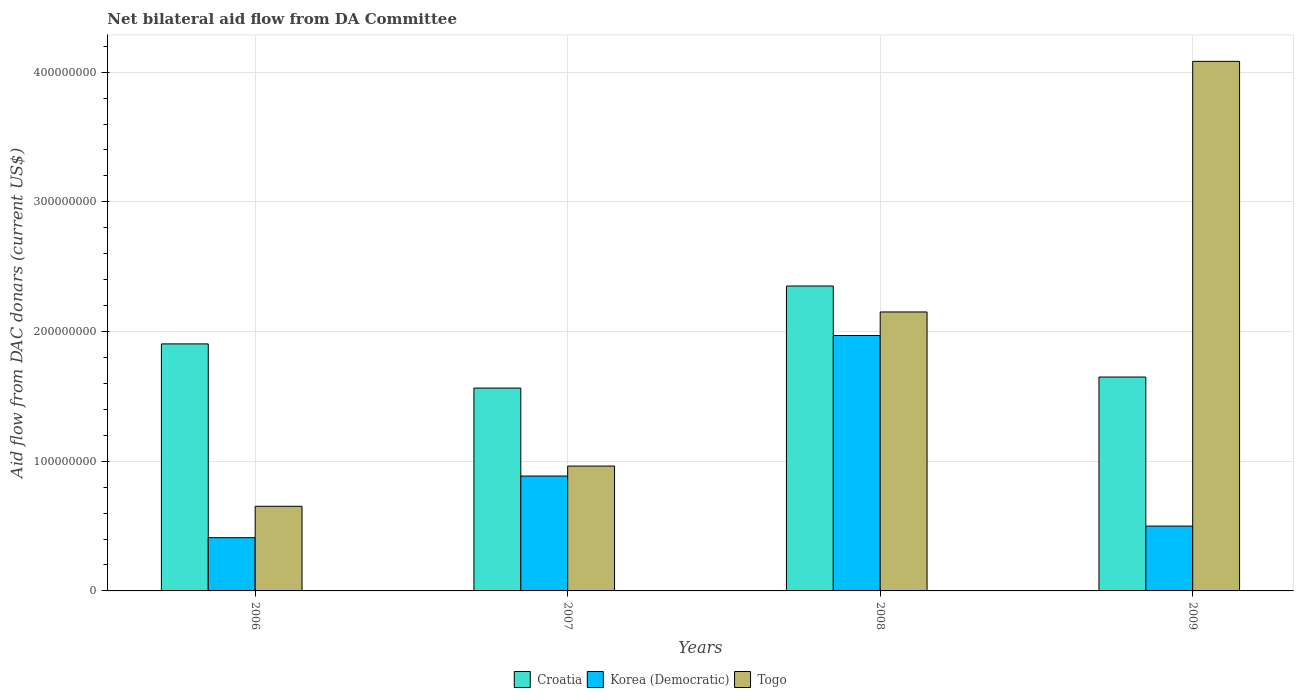How many different coloured bars are there?
Offer a terse response. 3. How many groups of bars are there?
Give a very brief answer. 4. Are the number of bars on each tick of the X-axis equal?
Give a very brief answer. Yes. How many bars are there on the 4th tick from the left?
Ensure brevity in your answer.  3. In how many cases, is the number of bars for a given year not equal to the number of legend labels?
Provide a succinct answer. 0. What is the aid flow in in Croatia in 2009?
Provide a succinct answer. 1.65e+08. Across all years, what is the maximum aid flow in in Korea (Democratic)?
Your answer should be very brief. 1.97e+08. Across all years, what is the minimum aid flow in in Croatia?
Your answer should be compact. 1.56e+08. In which year was the aid flow in in Togo maximum?
Provide a succinct answer. 2009. What is the total aid flow in in Korea (Democratic) in the graph?
Your answer should be compact. 3.77e+08. What is the difference between the aid flow in in Croatia in 2007 and that in 2009?
Provide a short and direct response. -8.51e+06. What is the difference between the aid flow in in Togo in 2008 and the aid flow in in Korea (Democratic) in 2009?
Your answer should be very brief. 1.65e+08. What is the average aid flow in in Korea (Democratic) per year?
Your answer should be very brief. 9.41e+07. In the year 2008, what is the difference between the aid flow in in Croatia and aid flow in in Korea (Democratic)?
Offer a very short reply. 3.82e+07. What is the ratio of the aid flow in in Korea (Democratic) in 2007 to that in 2009?
Your response must be concise. 1.77. Is the aid flow in in Korea (Democratic) in 2006 less than that in 2007?
Make the answer very short. Yes. What is the difference between the highest and the second highest aid flow in in Croatia?
Your answer should be very brief. 4.46e+07. What is the difference between the highest and the lowest aid flow in in Togo?
Your answer should be very brief. 3.43e+08. What does the 2nd bar from the left in 2009 represents?
Offer a very short reply. Korea (Democratic). What does the 1st bar from the right in 2006 represents?
Make the answer very short. Togo. How many bars are there?
Make the answer very short. 12. Are all the bars in the graph horizontal?
Your answer should be compact. No. How many years are there in the graph?
Provide a succinct answer. 4. What is the difference between two consecutive major ticks on the Y-axis?
Your answer should be compact. 1.00e+08. Does the graph contain any zero values?
Ensure brevity in your answer.  No. Does the graph contain grids?
Offer a very short reply. Yes. Where does the legend appear in the graph?
Offer a terse response. Bottom center. How many legend labels are there?
Provide a short and direct response. 3. How are the legend labels stacked?
Provide a short and direct response. Horizontal. What is the title of the graph?
Make the answer very short. Net bilateral aid flow from DA Committee. Does "Sri Lanka" appear as one of the legend labels in the graph?
Give a very brief answer. No. What is the label or title of the Y-axis?
Keep it short and to the point. Aid flow from DAC donars (current US$). What is the Aid flow from DAC donars (current US$) of Croatia in 2006?
Ensure brevity in your answer.  1.90e+08. What is the Aid flow from DAC donars (current US$) in Korea (Democratic) in 2006?
Provide a succinct answer. 4.10e+07. What is the Aid flow from DAC donars (current US$) in Togo in 2006?
Keep it short and to the point. 6.52e+07. What is the Aid flow from DAC donars (current US$) of Croatia in 2007?
Your answer should be compact. 1.56e+08. What is the Aid flow from DAC donars (current US$) in Korea (Democratic) in 2007?
Provide a succinct answer. 8.86e+07. What is the Aid flow from DAC donars (current US$) in Togo in 2007?
Your answer should be compact. 9.63e+07. What is the Aid flow from DAC donars (current US$) in Croatia in 2008?
Give a very brief answer. 2.35e+08. What is the Aid flow from DAC donars (current US$) in Korea (Democratic) in 2008?
Offer a terse response. 1.97e+08. What is the Aid flow from DAC donars (current US$) in Togo in 2008?
Make the answer very short. 2.15e+08. What is the Aid flow from DAC donars (current US$) of Croatia in 2009?
Your answer should be compact. 1.65e+08. What is the Aid flow from DAC donars (current US$) of Korea (Democratic) in 2009?
Provide a succinct answer. 5.00e+07. What is the Aid flow from DAC donars (current US$) of Togo in 2009?
Your answer should be compact. 4.08e+08. Across all years, what is the maximum Aid flow from DAC donars (current US$) in Croatia?
Keep it short and to the point. 2.35e+08. Across all years, what is the maximum Aid flow from DAC donars (current US$) in Korea (Democratic)?
Provide a succinct answer. 1.97e+08. Across all years, what is the maximum Aid flow from DAC donars (current US$) in Togo?
Provide a short and direct response. 4.08e+08. Across all years, what is the minimum Aid flow from DAC donars (current US$) of Croatia?
Give a very brief answer. 1.56e+08. Across all years, what is the minimum Aid flow from DAC donars (current US$) of Korea (Democratic)?
Your answer should be very brief. 4.10e+07. Across all years, what is the minimum Aid flow from DAC donars (current US$) in Togo?
Your answer should be very brief. 6.52e+07. What is the total Aid flow from DAC donars (current US$) of Croatia in the graph?
Provide a short and direct response. 7.47e+08. What is the total Aid flow from DAC donars (current US$) in Korea (Democratic) in the graph?
Ensure brevity in your answer.  3.77e+08. What is the total Aid flow from DAC donars (current US$) of Togo in the graph?
Your response must be concise. 7.85e+08. What is the difference between the Aid flow from DAC donars (current US$) in Croatia in 2006 and that in 2007?
Make the answer very short. 3.41e+07. What is the difference between the Aid flow from DAC donars (current US$) of Korea (Democratic) in 2006 and that in 2007?
Ensure brevity in your answer.  -4.75e+07. What is the difference between the Aid flow from DAC donars (current US$) of Togo in 2006 and that in 2007?
Provide a short and direct response. -3.10e+07. What is the difference between the Aid flow from DAC donars (current US$) in Croatia in 2006 and that in 2008?
Offer a very short reply. -4.46e+07. What is the difference between the Aid flow from DAC donars (current US$) in Korea (Democratic) in 2006 and that in 2008?
Make the answer very short. -1.56e+08. What is the difference between the Aid flow from DAC donars (current US$) of Togo in 2006 and that in 2008?
Ensure brevity in your answer.  -1.50e+08. What is the difference between the Aid flow from DAC donars (current US$) of Croatia in 2006 and that in 2009?
Your answer should be compact. 2.56e+07. What is the difference between the Aid flow from DAC donars (current US$) of Korea (Democratic) in 2006 and that in 2009?
Keep it short and to the point. -8.93e+06. What is the difference between the Aid flow from DAC donars (current US$) in Togo in 2006 and that in 2009?
Provide a succinct answer. -3.43e+08. What is the difference between the Aid flow from DAC donars (current US$) of Croatia in 2007 and that in 2008?
Offer a terse response. -7.87e+07. What is the difference between the Aid flow from DAC donars (current US$) of Korea (Democratic) in 2007 and that in 2008?
Offer a very short reply. -1.08e+08. What is the difference between the Aid flow from DAC donars (current US$) of Togo in 2007 and that in 2008?
Keep it short and to the point. -1.19e+08. What is the difference between the Aid flow from DAC donars (current US$) in Croatia in 2007 and that in 2009?
Ensure brevity in your answer.  -8.51e+06. What is the difference between the Aid flow from DAC donars (current US$) in Korea (Democratic) in 2007 and that in 2009?
Keep it short and to the point. 3.86e+07. What is the difference between the Aid flow from DAC donars (current US$) in Togo in 2007 and that in 2009?
Your answer should be very brief. -3.12e+08. What is the difference between the Aid flow from DAC donars (current US$) in Croatia in 2008 and that in 2009?
Offer a terse response. 7.02e+07. What is the difference between the Aid flow from DAC donars (current US$) of Korea (Democratic) in 2008 and that in 2009?
Ensure brevity in your answer.  1.47e+08. What is the difference between the Aid flow from DAC donars (current US$) in Togo in 2008 and that in 2009?
Your answer should be very brief. -1.93e+08. What is the difference between the Aid flow from DAC donars (current US$) in Croatia in 2006 and the Aid flow from DAC donars (current US$) in Korea (Democratic) in 2007?
Make the answer very short. 1.02e+08. What is the difference between the Aid flow from DAC donars (current US$) of Croatia in 2006 and the Aid flow from DAC donars (current US$) of Togo in 2007?
Provide a succinct answer. 9.42e+07. What is the difference between the Aid flow from DAC donars (current US$) of Korea (Democratic) in 2006 and the Aid flow from DAC donars (current US$) of Togo in 2007?
Your answer should be compact. -5.52e+07. What is the difference between the Aid flow from DAC donars (current US$) in Croatia in 2006 and the Aid flow from DAC donars (current US$) in Korea (Democratic) in 2008?
Offer a terse response. -6.47e+06. What is the difference between the Aid flow from DAC donars (current US$) of Croatia in 2006 and the Aid flow from DAC donars (current US$) of Togo in 2008?
Ensure brevity in your answer.  -2.46e+07. What is the difference between the Aid flow from DAC donars (current US$) of Korea (Democratic) in 2006 and the Aid flow from DAC donars (current US$) of Togo in 2008?
Provide a succinct answer. -1.74e+08. What is the difference between the Aid flow from DAC donars (current US$) in Croatia in 2006 and the Aid flow from DAC donars (current US$) in Korea (Democratic) in 2009?
Keep it short and to the point. 1.40e+08. What is the difference between the Aid flow from DAC donars (current US$) of Croatia in 2006 and the Aid flow from DAC donars (current US$) of Togo in 2009?
Make the answer very short. -2.18e+08. What is the difference between the Aid flow from DAC donars (current US$) of Korea (Democratic) in 2006 and the Aid flow from DAC donars (current US$) of Togo in 2009?
Your answer should be very brief. -3.67e+08. What is the difference between the Aid flow from DAC donars (current US$) in Croatia in 2007 and the Aid flow from DAC donars (current US$) in Korea (Democratic) in 2008?
Make the answer very short. -4.05e+07. What is the difference between the Aid flow from DAC donars (current US$) in Croatia in 2007 and the Aid flow from DAC donars (current US$) in Togo in 2008?
Offer a terse response. -5.87e+07. What is the difference between the Aid flow from DAC donars (current US$) of Korea (Democratic) in 2007 and the Aid flow from DAC donars (current US$) of Togo in 2008?
Ensure brevity in your answer.  -1.27e+08. What is the difference between the Aid flow from DAC donars (current US$) in Croatia in 2007 and the Aid flow from DAC donars (current US$) in Korea (Democratic) in 2009?
Ensure brevity in your answer.  1.06e+08. What is the difference between the Aid flow from DAC donars (current US$) of Croatia in 2007 and the Aid flow from DAC donars (current US$) of Togo in 2009?
Your answer should be compact. -2.52e+08. What is the difference between the Aid flow from DAC donars (current US$) in Korea (Democratic) in 2007 and the Aid flow from DAC donars (current US$) in Togo in 2009?
Keep it short and to the point. -3.20e+08. What is the difference between the Aid flow from DAC donars (current US$) of Croatia in 2008 and the Aid flow from DAC donars (current US$) of Korea (Democratic) in 2009?
Ensure brevity in your answer.  1.85e+08. What is the difference between the Aid flow from DAC donars (current US$) of Croatia in 2008 and the Aid flow from DAC donars (current US$) of Togo in 2009?
Your answer should be compact. -1.73e+08. What is the difference between the Aid flow from DAC donars (current US$) of Korea (Democratic) in 2008 and the Aid flow from DAC donars (current US$) of Togo in 2009?
Keep it short and to the point. -2.11e+08. What is the average Aid flow from DAC donars (current US$) of Croatia per year?
Your answer should be very brief. 1.87e+08. What is the average Aid flow from DAC donars (current US$) in Korea (Democratic) per year?
Give a very brief answer. 9.41e+07. What is the average Aid flow from DAC donars (current US$) of Togo per year?
Ensure brevity in your answer.  1.96e+08. In the year 2006, what is the difference between the Aid flow from DAC donars (current US$) of Croatia and Aid flow from DAC donars (current US$) of Korea (Democratic)?
Keep it short and to the point. 1.49e+08. In the year 2006, what is the difference between the Aid flow from DAC donars (current US$) in Croatia and Aid flow from DAC donars (current US$) in Togo?
Your response must be concise. 1.25e+08. In the year 2006, what is the difference between the Aid flow from DAC donars (current US$) in Korea (Democratic) and Aid flow from DAC donars (current US$) in Togo?
Provide a succinct answer. -2.42e+07. In the year 2007, what is the difference between the Aid flow from DAC donars (current US$) of Croatia and Aid flow from DAC donars (current US$) of Korea (Democratic)?
Offer a very short reply. 6.78e+07. In the year 2007, what is the difference between the Aid flow from DAC donars (current US$) in Croatia and Aid flow from DAC donars (current US$) in Togo?
Ensure brevity in your answer.  6.01e+07. In the year 2007, what is the difference between the Aid flow from DAC donars (current US$) of Korea (Democratic) and Aid flow from DAC donars (current US$) of Togo?
Offer a terse response. -7.69e+06. In the year 2008, what is the difference between the Aid flow from DAC donars (current US$) in Croatia and Aid flow from DAC donars (current US$) in Korea (Democratic)?
Your answer should be very brief. 3.82e+07. In the year 2008, what is the difference between the Aid flow from DAC donars (current US$) in Croatia and Aid flow from DAC donars (current US$) in Togo?
Your answer should be very brief. 2.00e+07. In the year 2008, what is the difference between the Aid flow from DAC donars (current US$) in Korea (Democratic) and Aid flow from DAC donars (current US$) in Togo?
Offer a very short reply. -1.82e+07. In the year 2009, what is the difference between the Aid flow from DAC donars (current US$) of Croatia and Aid flow from DAC donars (current US$) of Korea (Democratic)?
Your response must be concise. 1.15e+08. In the year 2009, what is the difference between the Aid flow from DAC donars (current US$) in Croatia and Aid flow from DAC donars (current US$) in Togo?
Keep it short and to the point. -2.43e+08. In the year 2009, what is the difference between the Aid flow from DAC donars (current US$) of Korea (Democratic) and Aid flow from DAC donars (current US$) of Togo?
Provide a short and direct response. -3.58e+08. What is the ratio of the Aid flow from DAC donars (current US$) of Croatia in 2006 to that in 2007?
Give a very brief answer. 1.22. What is the ratio of the Aid flow from DAC donars (current US$) of Korea (Democratic) in 2006 to that in 2007?
Offer a terse response. 0.46. What is the ratio of the Aid flow from DAC donars (current US$) in Togo in 2006 to that in 2007?
Your answer should be compact. 0.68. What is the ratio of the Aid flow from DAC donars (current US$) of Croatia in 2006 to that in 2008?
Provide a succinct answer. 0.81. What is the ratio of the Aid flow from DAC donars (current US$) in Korea (Democratic) in 2006 to that in 2008?
Offer a terse response. 0.21. What is the ratio of the Aid flow from DAC donars (current US$) in Togo in 2006 to that in 2008?
Give a very brief answer. 0.3. What is the ratio of the Aid flow from DAC donars (current US$) in Croatia in 2006 to that in 2009?
Ensure brevity in your answer.  1.15. What is the ratio of the Aid flow from DAC donars (current US$) in Korea (Democratic) in 2006 to that in 2009?
Provide a short and direct response. 0.82. What is the ratio of the Aid flow from DAC donars (current US$) of Togo in 2006 to that in 2009?
Your answer should be very brief. 0.16. What is the ratio of the Aid flow from DAC donars (current US$) in Croatia in 2007 to that in 2008?
Make the answer very short. 0.67. What is the ratio of the Aid flow from DAC donars (current US$) in Korea (Democratic) in 2007 to that in 2008?
Make the answer very short. 0.45. What is the ratio of the Aid flow from DAC donars (current US$) in Togo in 2007 to that in 2008?
Your response must be concise. 0.45. What is the ratio of the Aid flow from DAC donars (current US$) in Croatia in 2007 to that in 2009?
Offer a terse response. 0.95. What is the ratio of the Aid flow from DAC donars (current US$) of Korea (Democratic) in 2007 to that in 2009?
Provide a short and direct response. 1.77. What is the ratio of the Aid flow from DAC donars (current US$) in Togo in 2007 to that in 2009?
Give a very brief answer. 0.24. What is the ratio of the Aid flow from DAC donars (current US$) in Croatia in 2008 to that in 2009?
Provide a short and direct response. 1.43. What is the ratio of the Aid flow from DAC donars (current US$) in Korea (Democratic) in 2008 to that in 2009?
Offer a very short reply. 3.94. What is the ratio of the Aid flow from DAC donars (current US$) of Togo in 2008 to that in 2009?
Make the answer very short. 0.53. What is the difference between the highest and the second highest Aid flow from DAC donars (current US$) of Croatia?
Offer a very short reply. 4.46e+07. What is the difference between the highest and the second highest Aid flow from DAC donars (current US$) of Korea (Democratic)?
Your answer should be very brief. 1.08e+08. What is the difference between the highest and the second highest Aid flow from DAC donars (current US$) of Togo?
Provide a succinct answer. 1.93e+08. What is the difference between the highest and the lowest Aid flow from DAC donars (current US$) of Croatia?
Provide a succinct answer. 7.87e+07. What is the difference between the highest and the lowest Aid flow from DAC donars (current US$) in Korea (Democratic)?
Your response must be concise. 1.56e+08. What is the difference between the highest and the lowest Aid flow from DAC donars (current US$) of Togo?
Your answer should be compact. 3.43e+08. 